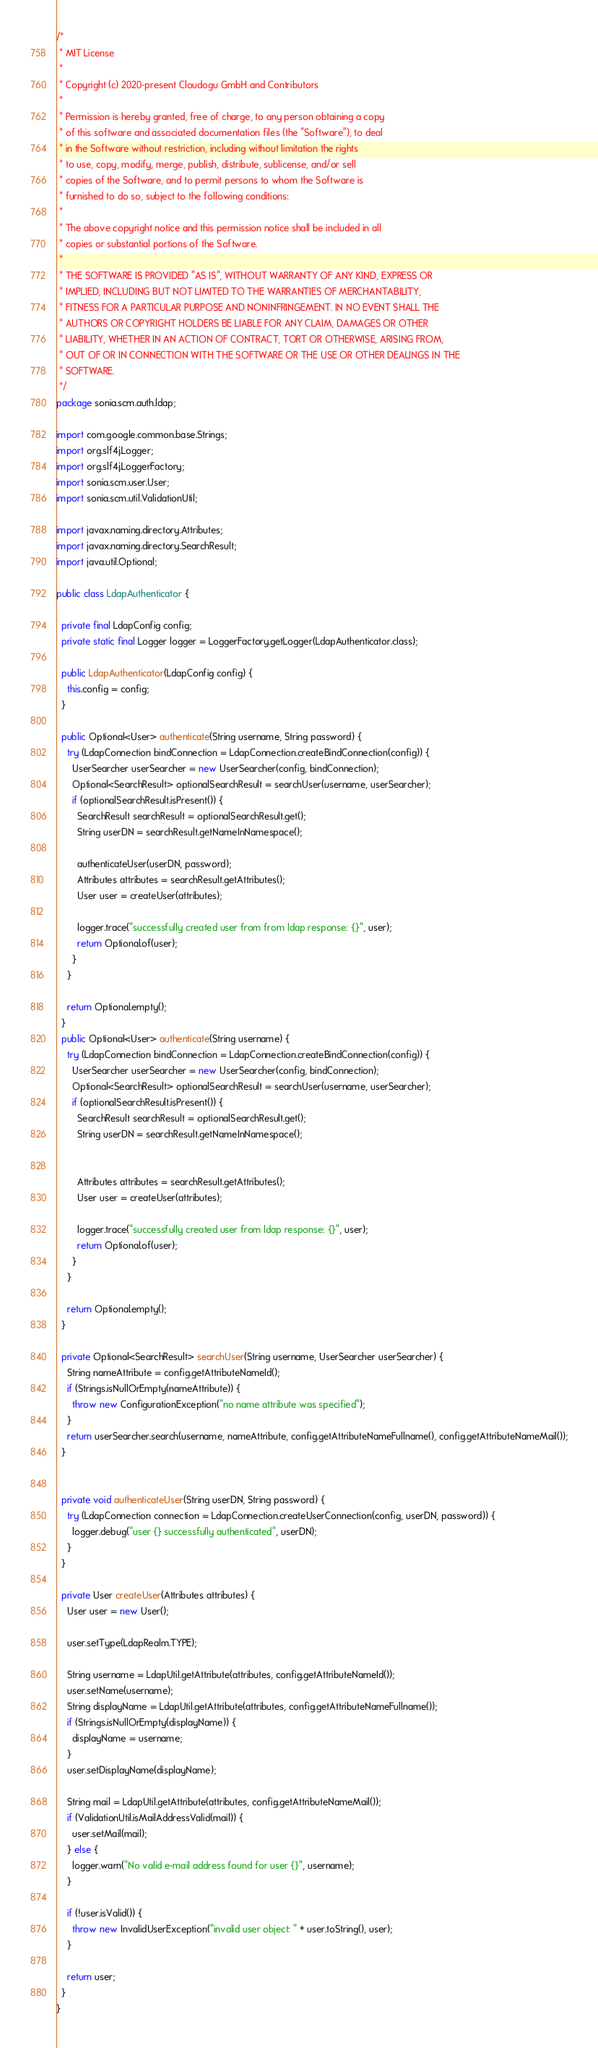<code> <loc_0><loc_0><loc_500><loc_500><_Java_>/*
 * MIT License
 *
 * Copyright (c) 2020-present Cloudogu GmbH and Contributors
 *
 * Permission is hereby granted, free of charge, to any person obtaining a copy
 * of this software and associated documentation files (the "Software"), to deal
 * in the Software without restriction, including without limitation the rights
 * to use, copy, modify, merge, publish, distribute, sublicense, and/or sell
 * copies of the Software, and to permit persons to whom the Software is
 * furnished to do so, subject to the following conditions:
 *
 * The above copyright notice and this permission notice shall be included in all
 * copies or substantial portions of the Software.
 *
 * THE SOFTWARE IS PROVIDED "AS IS", WITHOUT WARRANTY OF ANY KIND, EXPRESS OR
 * IMPLIED, INCLUDING BUT NOT LIMITED TO THE WARRANTIES OF MERCHANTABILITY,
 * FITNESS FOR A PARTICULAR PURPOSE AND NONINFRINGEMENT. IN NO EVENT SHALL THE
 * AUTHORS OR COPYRIGHT HOLDERS BE LIABLE FOR ANY CLAIM, DAMAGES OR OTHER
 * LIABILITY, WHETHER IN AN ACTION OF CONTRACT, TORT OR OTHERWISE, ARISING FROM,
 * OUT OF OR IN CONNECTION WITH THE SOFTWARE OR THE USE OR OTHER DEALINGS IN THE
 * SOFTWARE.
 */
package sonia.scm.auth.ldap;

import com.google.common.base.Strings;
import org.slf4j.Logger;
import org.slf4j.LoggerFactory;
import sonia.scm.user.User;
import sonia.scm.util.ValidationUtil;

import javax.naming.directory.Attributes;
import javax.naming.directory.SearchResult;
import java.util.Optional;

public class LdapAuthenticator {

  private final LdapConfig config;
  private static final Logger logger = LoggerFactory.getLogger(LdapAuthenticator.class);

  public LdapAuthenticator(LdapConfig config) {
    this.config = config;
  }

  public Optional<User> authenticate(String username, String password) {
    try (LdapConnection bindConnection = LdapConnection.createBindConnection(config)) {
      UserSearcher userSearcher = new UserSearcher(config, bindConnection);
      Optional<SearchResult> optionalSearchResult = searchUser(username, userSearcher);
      if (optionalSearchResult.isPresent()) {
        SearchResult searchResult = optionalSearchResult.get();
        String userDN = searchResult.getNameInNamespace();

        authenticateUser(userDN, password);
        Attributes attributes = searchResult.getAttributes();
        User user = createUser(attributes);

        logger.trace("successfully created user from from ldap response: {}", user);
        return Optional.of(user);
      }
    }

    return Optional.empty();
  }
  public Optional<User> authenticate(String username) {
    try (LdapConnection bindConnection = LdapConnection.createBindConnection(config)) {
      UserSearcher userSearcher = new UserSearcher(config, bindConnection);
      Optional<SearchResult> optionalSearchResult = searchUser(username, userSearcher);
      if (optionalSearchResult.isPresent()) {
        SearchResult searchResult = optionalSearchResult.get();
        String userDN = searchResult.getNameInNamespace();


        Attributes attributes = searchResult.getAttributes();
        User user = createUser(attributes);

        logger.trace("successfully created user from ldap response: {}", user);
        return Optional.of(user);
      }
    }

    return Optional.empty();
  }

  private Optional<SearchResult> searchUser(String username, UserSearcher userSearcher) {
    String nameAttribute = config.getAttributeNameId();
    if (Strings.isNullOrEmpty(nameAttribute)) {
      throw new ConfigurationException("no name attribute was specified");
    }
    return userSearcher.search(username, nameAttribute, config.getAttributeNameFullname(), config.getAttributeNameMail());
  }


  private void authenticateUser(String userDN, String password) {
    try (LdapConnection connection = LdapConnection.createUserConnection(config, userDN, password)) {
      logger.debug("user {} successfully authenticated", userDN);
    }
  }

  private User createUser(Attributes attributes) {
    User user = new User();

    user.setType(LdapRealm.TYPE);

    String username = LdapUtil.getAttribute(attributes, config.getAttributeNameId());
    user.setName(username);
    String displayName = LdapUtil.getAttribute(attributes, config.getAttributeNameFullname());
    if (Strings.isNullOrEmpty(displayName)) {
      displayName = username;
    }
    user.setDisplayName(displayName);

    String mail = LdapUtil.getAttribute(attributes, config.getAttributeNameMail());
    if (ValidationUtil.isMailAddressValid(mail)) {
      user.setMail(mail);
    } else {
      logger.warn("No valid e-mail address found for user {}", username);
    }

    if (!user.isValid()) {
      throw new InvalidUserException("invalid user object: " + user.toString(), user);
    }

    return user;
  }
}
</code> 